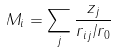Convert formula to latex. <formula><loc_0><loc_0><loc_500><loc_500>M _ { i } = \sum _ { j } \frac { z _ { j } } { r _ { i j } / r _ { 0 } }</formula> 